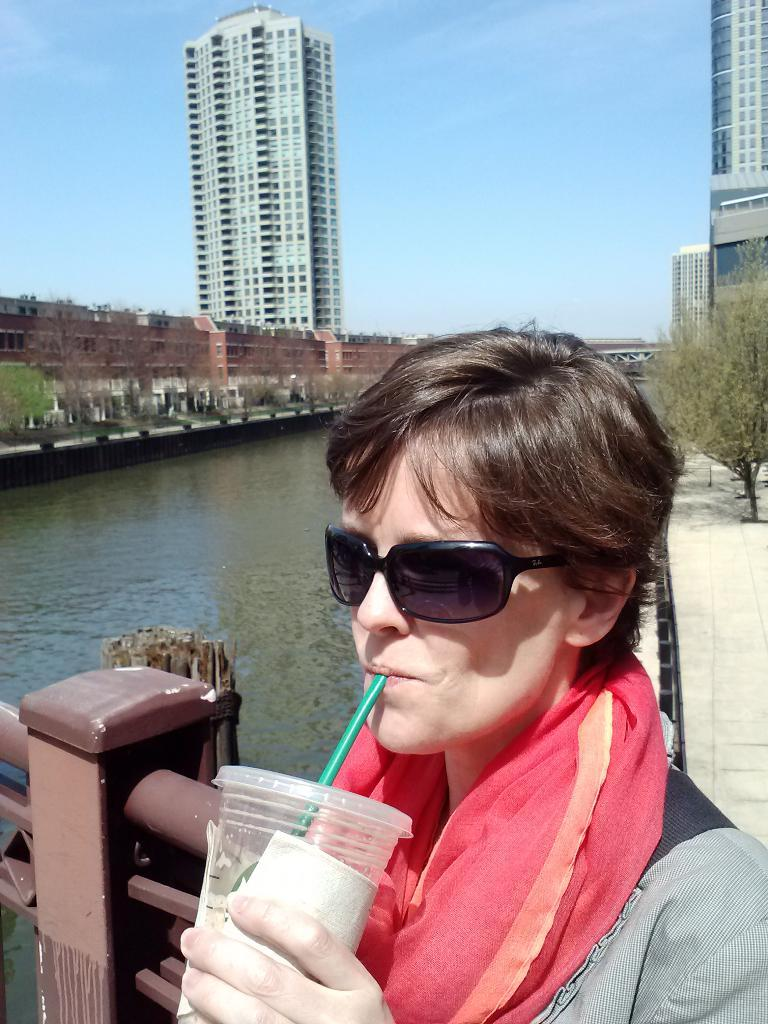What is the person in the image doing with the glass? The person is holding a glass with tissue and drinking with a straw. What protective gear is the person wearing? The person is wearing goggles. What can be seen in the background of the image? There is a walkway, rods, water, trees, buildings, and the sky visible in the background of the image. What type of pie is the fireman eating in the image? There is no fireman or pie present in the image. How does the sand in the image affect the person's ability to drink? There is no sand present in the image, so it does not affect the person's ability to drink. 